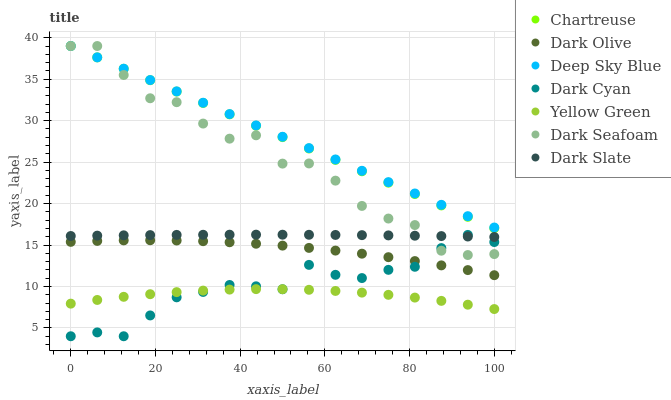Does Yellow Green have the minimum area under the curve?
Answer yes or no. Yes. Does Deep Sky Blue have the maximum area under the curve?
Answer yes or no. Yes. Does Dark Olive have the minimum area under the curve?
Answer yes or no. No. Does Dark Olive have the maximum area under the curve?
Answer yes or no. No. Is Chartreuse the smoothest?
Answer yes or no. Yes. Is Dark Seafoam the roughest?
Answer yes or no. Yes. Is Dark Olive the smoothest?
Answer yes or no. No. Is Dark Olive the roughest?
Answer yes or no. No. Does Dark Cyan have the lowest value?
Answer yes or no. Yes. Does Dark Olive have the lowest value?
Answer yes or no. No. Does Deep Sky Blue have the highest value?
Answer yes or no. Yes. Does Dark Olive have the highest value?
Answer yes or no. No. Is Dark Olive less than Deep Sky Blue?
Answer yes or no. Yes. Is Chartreuse greater than Yellow Green?
Answer yes or no. Yes. Does Deep Sky Blue intersect Chartreuse?
Answer yes or no. Yes. Is Deep Sky Blue less than Chartreuse?
Answer yes or no. No. Is Deep Sky Blue greater than Chartreuse?
Answer yes or no. No. Does Dark Olive intersect Deep Sky Blue?
Answer yes or no. No. 